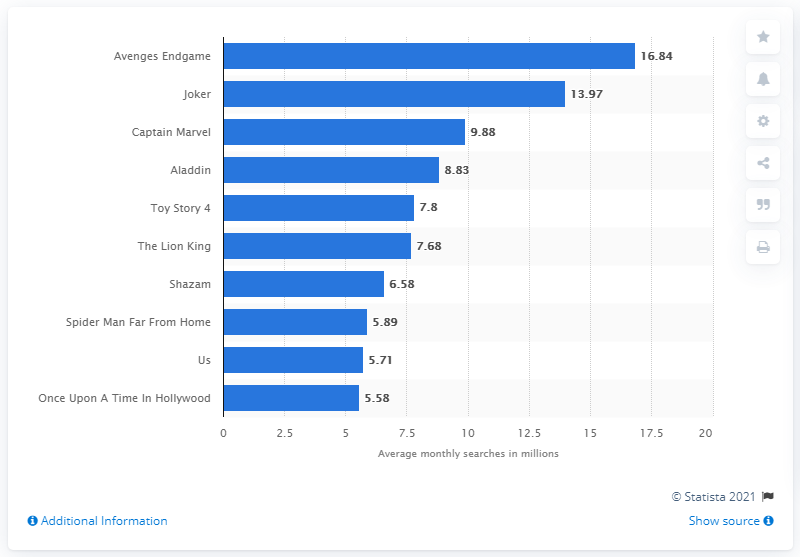Give some essential details in this illustration. The monthly number of web searches for Avengers: Endgame is 16.84. 